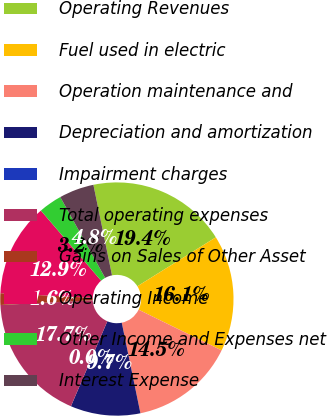<chart> <loc_0><loc_0><loc_500><loc_500><pie_chart><fcel>Operating Revenues<fcel>Fuel used in electric<fcel>Operation maintenance and<fcel>Depreciation and amortization<fcel>Impairment charges<fcel>Total operating expenses<fcel>Gains on Sales of Other Asset<fcel>Operating Income<fcel>Other Income and Expenses net<fcel>Interest Expense<nl><fcel>19.35%<fcel>16.13%<fcel>14.51%<fcel>9.68%<fcel>0.0%<fcel>17.74%<fcel>1.62%<fcel>12.9%<fcel>3.23%<fcel>4.84%<nl></chart> 